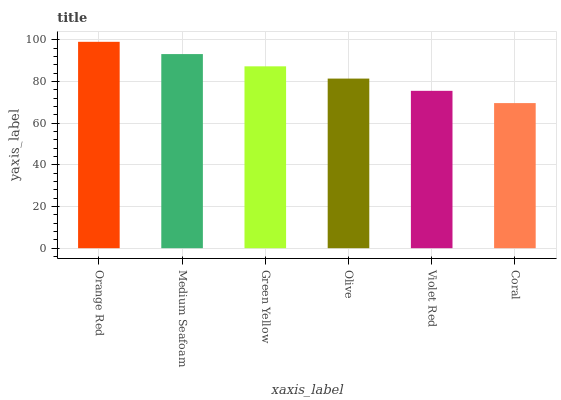Is Coral the minimum?
Answer yes or no. Yes. Is Orange Red the maximum?
Answer yes or no. Yes. Is Medium Seafoam the minimum?
Answer yes or no. No. Is Medium Seafoam the maximum?
Answer yes or no. No. Is Orange Red greater than Medium Seafoam?
Answer yes or no. Yes. Is Medium Seafoam less than Orange Red?
Answer yes or no. Yes. Is Medium Seafoam greater than Orange Red?
Answer yes or no. No. Is Orange Red less than Medium Seafoam?
Answer yes or no. No. Is Green Yellow the high median?
Answer yes or no. Yes. Is Olive the low median?
Answer yes or no. Yes. Is Violet Red the high median?
Answer yes or no. No. Is Green Yellow the low median?
Answer yes or no. No. 